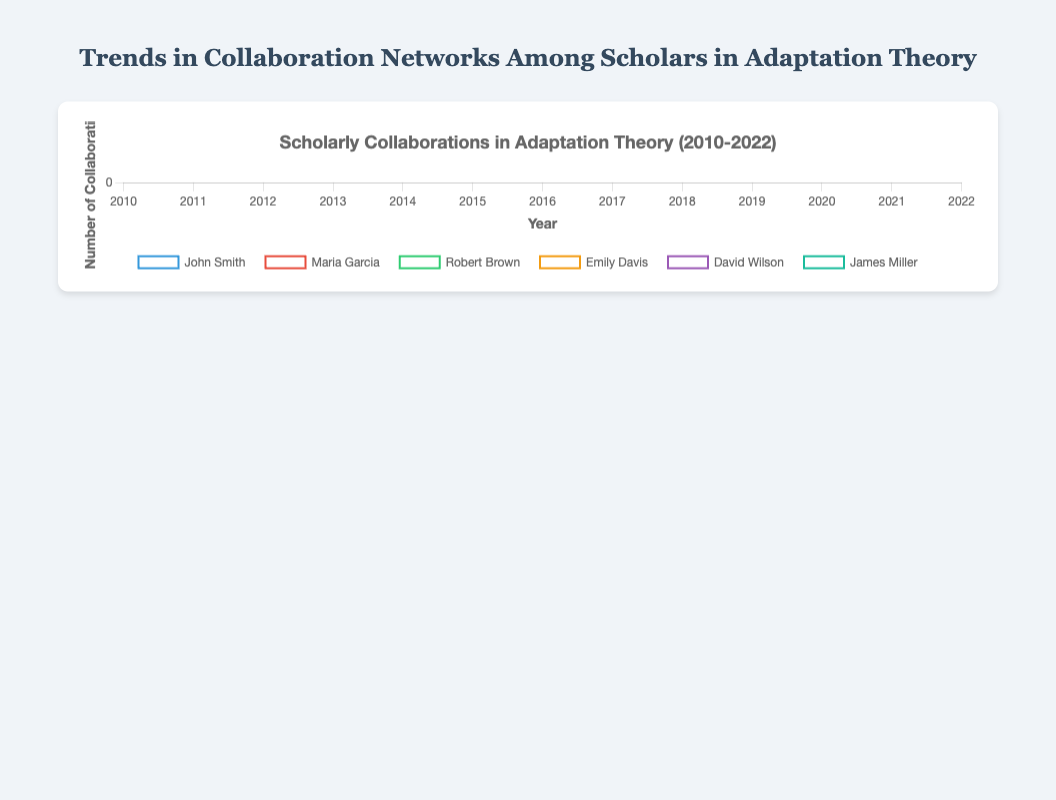What was the highest number of collaborations James Miller had between 2010 and 2022? To find the highest number of collaborations, look at James Miller’s data points and find the maximum value. James Miller's collaborations in each year are [5, 5, 6, 7, 8, 9, 10, 10, 11, 12, 13, 13, 14]. The highest number is 14.
Answer: 14 Who had more collaborations in 2015, John Smith or Maria Garcia? Compare the number of collaborations for John Smith and Maria Garcia in 2015. John Smith had 7 collaborations, while Maria Garcia had 6. Therefore, John Smith had more collaborations in 2015.
Answer: John Smith What is the average number of collaborations for Emily Davis from 2010 to 2022? Sum up all the collaboration numbers for Emily Davis and then divide by the number of years. Emily Davis’s data points are [0, 1, 1, 2, 3, 3, 4, 5, 5, 4, 6, 7, 8]. The sum is 49, and there are 13 years. The average is 49/13, which is approximately 3.77.
Answer: 3.77 Between 2017 and 2020, who showed the most significant increase in collaborations, Robert Brown or Patricia Johnson? Calculate the difference in collaborations between 2017 and 2020 for both scholars. Robert Brown's data points are [5, 6, 7, 7], resulting in an increase of 2 (7 - 5). Patricia Johnson's data points are [6, 6, 7, 8], resulting in an increase of 2 (8 - 6). Both showed the same increase.
Answer: Both Which scholar had the most steady (least variable) number of collaborations over the years? The variability can be assessed by the range (difference between the maximum and minimum values) of the collaboration numbers. Calculate the range for each scholar. John Smith: max 9, min 3 (range 6); Maria Garcia: max 12, min 2 (range 10); Robert Brown: max 9, min 1 (range 8); Emily Davis: max 8, min 0 (range 8); David Wilson: max 8, min 2 (range 6); James Miller: max 14, min 5 (range 9); Patricia Johnson: max 10, min 1 (range 9). Both John Smith and David Wilson have the smallest range of 6, indicating they had the most steady number of collaborations.
Answer: John Smith and David Wilson In which year did John Smith's number of collaborations peak? Find the year corresponding to the maximum value in John Smith’s data series [3, 4, 5, 6, 5, 7, 8, 8, 9, 7, 6, 6, 5]. The peak value is 9, which occurred in 2018.
Answer: 2018 How did the number of collaborations for David Wilson change between 2016 and 2019? Look at David Wilson’s data points for 2016 to 2019, which are [5, 4, 4, 5]. Note the changes for each year: 2016 to 2017 (-1), 2017 to 2018 (0), and 2018 to 2019 (+1). Overall, the number of collaborations decreased by 1 then returned to the previous level, indicating a minor fluctuation.
Answer: Minor fluctuation Which scholar had the highest increase in collaborations between 2010 and 2022? Calculate the difference between the first (2010) and last (2022) data points for each scholar, then identify the scholar with the highest difference: John Smith (5-3=2), Maria Garcia (12-2=10), Robert Brown (9-1=8), Emily Davis (8-0=8), David Wilson (8-2=6), James Miller (14-5=9), Patricia Johnson (10-1=9). Maria Garcia had the highest increase.
Answer: Maria Garcia Which scholar had the highest number of collaborations in 2019? Review the data points for the year 2019 for all scholars: John Smith (7), Maria Garcia (8), Robert Brown (7), Emily Davis (4), David Wilson (5), James Miller (12), Patricia Johnson (7). James Miller had the highest number of collaborations in that year.
Answer: James Miller 